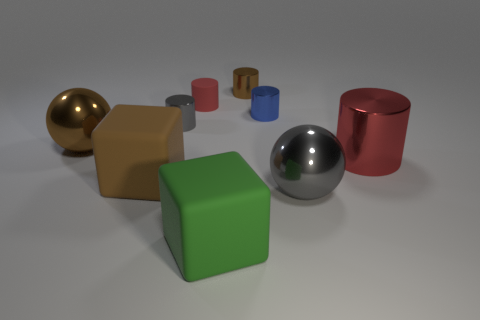Subtract all big cylinders. How many cylinders are left? 4 Subtract all gray cylinders. How many cylinders are left? 4 Subtract all purple cylinders. Subtract all purple cubes. How many cylinders are left? 5 Add 1 green rubber spheres. How many objects exist? 10 Subtract all spheres. How many objects are left? 7 Subtract 0 red balls. How many objects are left? 9 Subtract all small purple rubber balls. Subtract all gray cylinders. How many objects are left? 8 Add 7 blue objects. How many blue objects are left? 8 Add 7 red objects. How many red objects exist? 9 